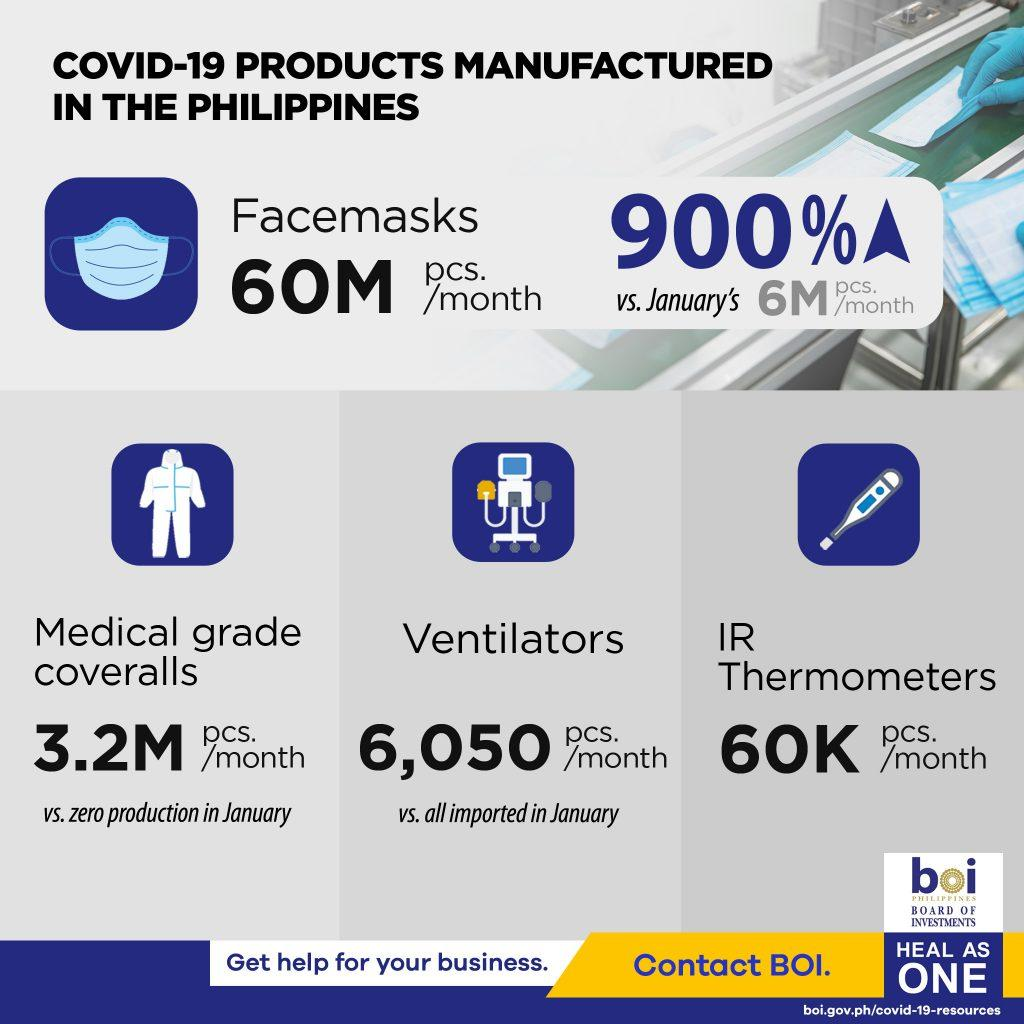Give some essential details in this illustration. The production of face-masks in the Philippines has increased by 900% due to the impact of COVID-19. In the Philippines, approximately 6,050 ventilators are manufactured monthly due to the impact of COVID-19. It is estimated that approximately 60,000 IR thermometers are manufactured per month in the Philippines due to the impact of COVID-19. 